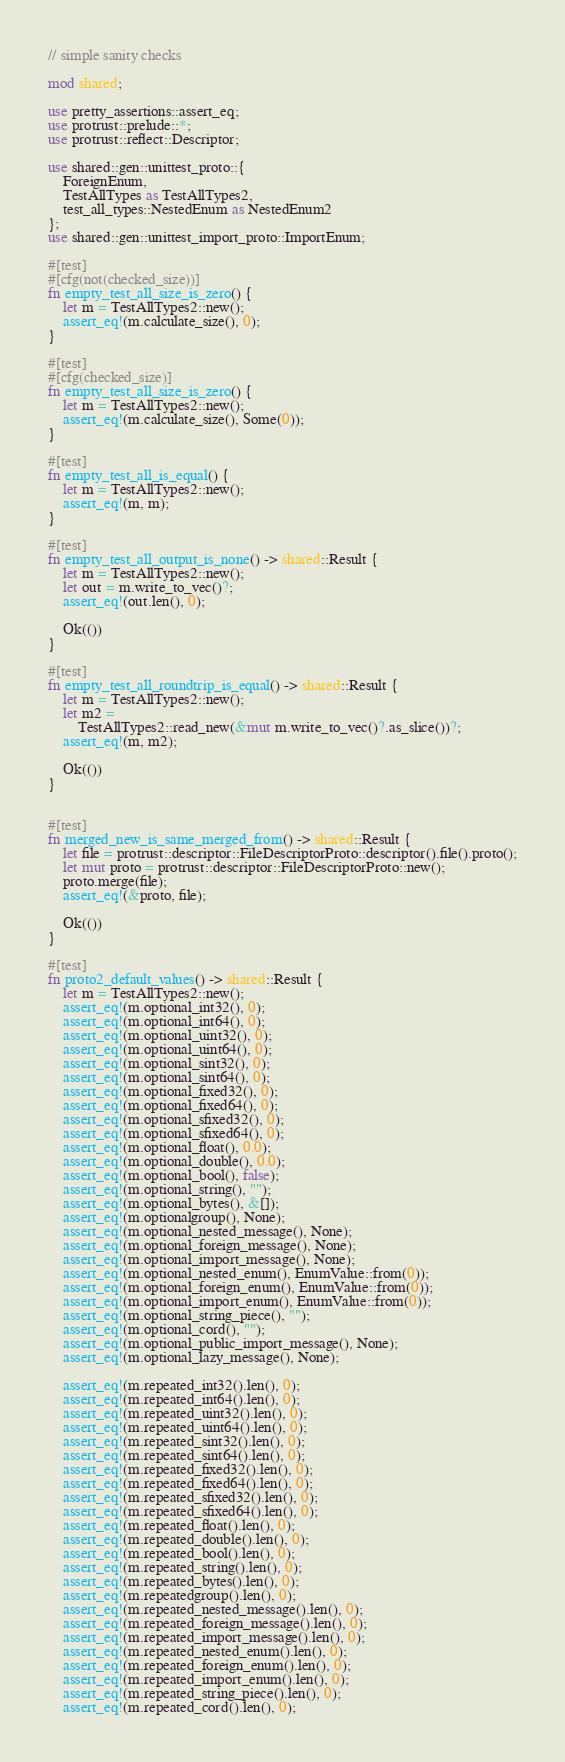Convert code to text. <code><loc_0><loc_0><loc_500><loc_500><_Rust_>// simple sanity checks

mod shared;

use pretty_assertions::assert_eq;
use protrust::prelude::*;
use protrust::reflect::Descriptor;

use shared::gen::unittest_proto::{
    ForeignEnum,
    TestAllTypes as TestAllTypes2, 
    test_all_types::NestedEnum as NestedEnum2
};
use shared::gen::unittest_import_proto::ImportEnum;

#[test]
#[cfg(not(checked_size))]
fn empty_test_all_size_is_zero() {
    let m = TestAllTypes2::new();
    assert_eq!(m.calculate_size(), 0);
}

#[test]
#[cfg(checked_size)]
fn empty_test_all_size_is_zero() {
    let m = TestAllTypes2::new();
    assert_eq!(m.calculate_size(), Some(0));
}

#[test]
fn empty_test_all_is_equal() {
    let m = TestAllTypes2::new();
    assert_eq!(m, m);
}

#[test]
fn empty_test_all_output_is_none() -> shared::Result {
    let m = TestAllTypes2::new();
    let out = m.write_to_vec()?;
    assert_eq!(out.len(), 0);

    Ok(())
}

#[test]
fn empty_test_all_roundtrip_is_equal() -> shared::Result {
    let m = TestAllTypes2::new();
    let m2 =
        TestAllTypes2::read_new(&mut m.write_to_vec()?.as_slice())?;
    assert_eq!(m, m2);

    Ok(())
}


#[test]
fn merged_new_is_same_merged_from() -> shared::Result {
    let file = protrust::descriptor::FileDescriptorProto::descriptor().file().proto();
    let mut proto = protrust::descriptor::FileDescriptorProto::new();
    proto.merge(file);
    assert_eq!(&proto, file);

    Ok(())
}

#[test]
fn proto2_default_values() -> shared::Result {
    let m = TestAllTypes2::new();
    assert_eq!(m.optional_int32(), 0);
    assert_eq!(m.optional_int64(), 0);
    assert_eq!(m.optional_uint32(), 0);
    assert_eq!(m.optional_uint64(), 0);
    assert_eq!(m.optional_sint32(), 0);
    assert_eq!(m.optional_sint64(), 0);
    assert_eq!(m.optional_fixed32(), 0);
    assert_eq!(m.optional_fixed64(), 0);
    assert_eq!(m.optional_sfixed32(), 0);
    assert_eq!(m.optional_sfixed64(), 0);
    assert_eq!(m.optional_float(), 0.0);
    assert_eq!(m.optional_double(), 0.0);
    assert_eq!(m.optional_bool(), false);
    assert_eq!(m.optional_string(), "");
    assert_eq!(m.optional_bytes(), &[]);
    assert_eq!(m.optionalgroup(), None);
    assert_eq!(m.optional_nested_message(), None);
    assert_eq!(m.optional_foreign_message(), None);
    assert_eq!(m.optional_import_message(), None);
    assert_eq!(m.optional_nested_enum(), EnumValue::from(0));
    assert_eq!(m.optional_foreign_enum(), EnumValue::from(0));
    assert_eq!(m.optional_import_enum(), EnumValue::from(0));
    assert_eq!(m.optional_string_piece(), "");
    assert_eq!(m.optional_cord(), "");
    assert_eq!(m.optional_public_import_message(), None);
    assert_eq!(m.optional_lazy_message(), None);

    assert_eq!(m.repeated_int32().len(), 0);
    assert_eq!(m.repeated_int64().len(), 0);
    assert_eq!(m.repeated_uint32().len(), 0);
    assert_eq!(m.repeated_uint64().len(), 0);
    assert_eq!(m.repeated_sint32().len(), 0);
    assert_eq!(m.repeated_sint64().len(), 0);
    assert_eq!(m.repeated_fixed32().len(), 0);
    assert_eq!(m.repeated_fixed64().len(), 0);
    assert_eq!(m.repeated_sfixed32().len(), 0);
    assert_eq!(m.repeated_sfixed64().len(), 0);
    assert_eq!(m.repeated_float().len(), 0);
    assert_eq!(m.repeated_double().len(), 0);
    assert_eq!(m.repeated_bool().len(), 0);
    assert_eq!(m.repeated_string().len(), 0);
    assert_eq!(m.repeated_bytes().len(), 0);
    assert_eq!(m.repeatedgroup().len(), 0);
    assert_eq!(m.repeated_nested_message().len(), 0);
    assert_eq!(m.repeated_foreign_message().len(), 0);
    assert_eq!(m.repeated_import_message().len(), 0);
    assert_eq!(m.repeated_nested_enum().len(), 0);
    assert_eq!(m.repeated_foreign_enum().len(), 0);
    assert_eq!(m.repeated_import_enum().len(), 0);
    assert_eq!(m.repeated_string_piece().len(), 0);
    assert_eq!(m.repeated_cord().len(), 0);</code> 